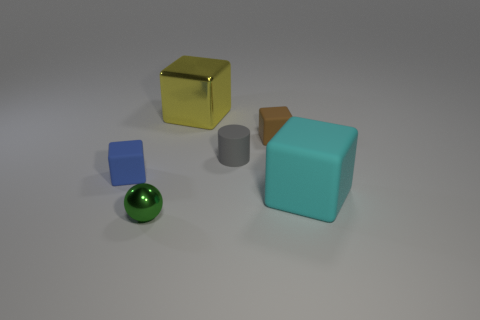Subtract all brown blocks. How many blocks are left? 3 Add 4 large purple spheres. How many objects exist? 10 Subtract all green cubes. Subtract all yellow cylinders. How many cubes are left? 4 Subtract all cylinders. How many objects are left? 5 Add 3 tiny green objects. How many tiny green objects are left? 4 Add 6 tiny brown rubber cylinders. How many tiny brown rubber cylinders exist? 6 Subtract 0 brown spheres. How many objects are left? 6 Subtract all small rubber objects. Subtract all big yellow things. How many objects are left? 2 